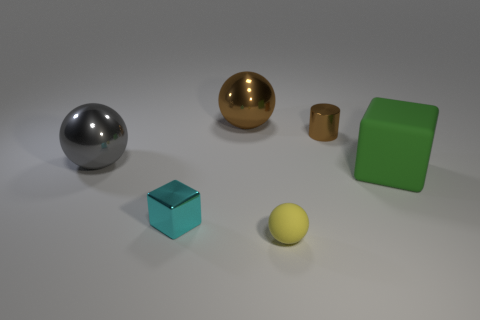There is a rubber object to the left of the big green object; are there any tiny brown shiny objects that are in front of it?
Keep it short and to the point. No. Does the rubber thing on the right side of the yellow ball have the same size as the shiny thing in front of the large green matte thing?
Provide a succinct answer. No. What number of small things are metallic things or cyan cubes?
Provide a succinct answer. 2. There is a sphere that is in front of the metallic sphere in front of the brown metal cylinder; what is it made of?
Ensure brevity in your answer.  Rubber. What shape is the metallic thing that is the same color as the tiny metal cylinder?
Ensure brevity in your answer.  Sphere. Are there any other tiny brown spheres made of the same material as the brown sphere?
Your response must be concise. No. Is the material of the green thing the same as the large thing that is to the left of the brown sphere?
Provide a short and direct response. No. There is a cylinder that is the same size as the cyan thing; what color is it?
Give a very brief answer. Brown. How big is the metallic sphere that is on the right side of the tiny shiny thing left of the small yellow sphere?
Provide a succinct answer. Large. There is a rubber ball; does it have the same color as the block that is right of the tiny cyan cube?
Provide a short and direct response. No. 